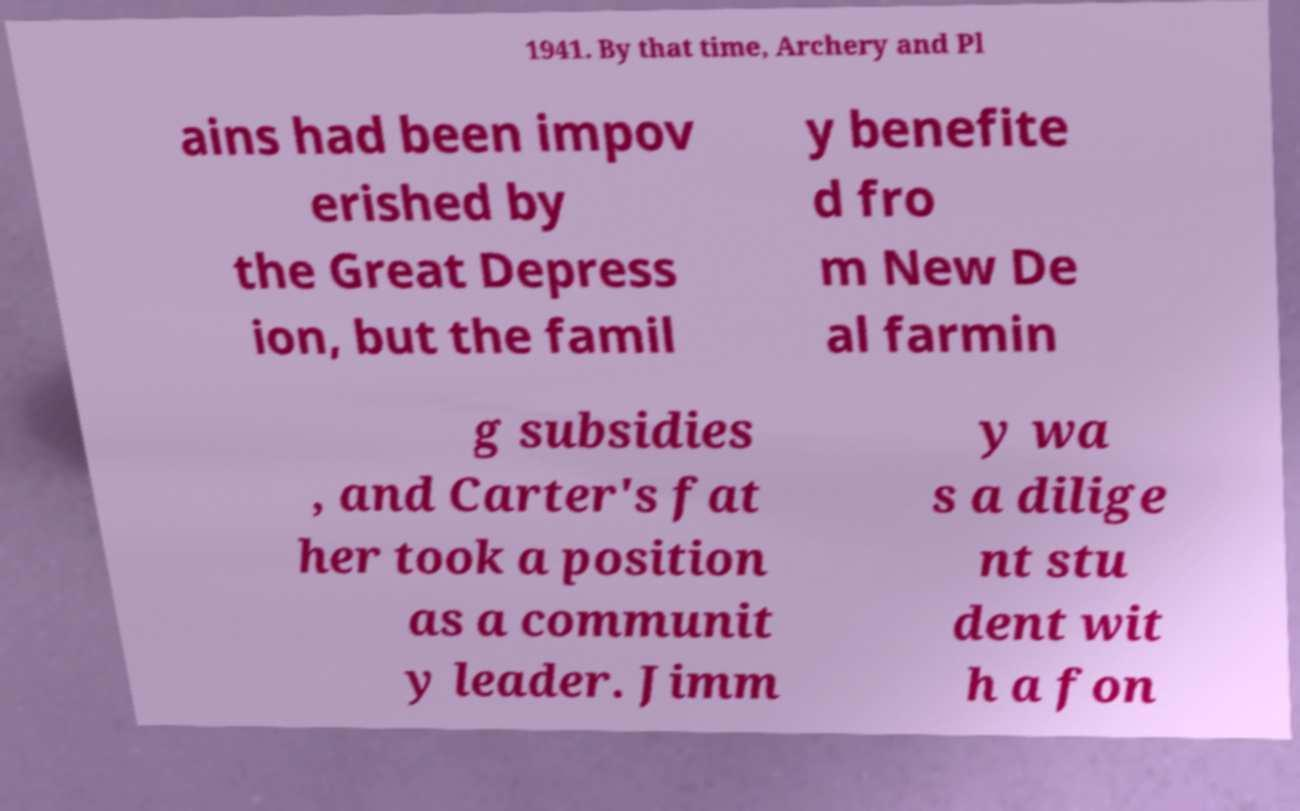Please identify and transcribe the text found in this image. 1941. By that time, Archery and Pl ains had been impov erished by the Great Depress ion, but the famil y benefite d fro m New De al farmin g subsidies , and Carter's fat her took a position as a communit y leader. Jimm y wa s a dilige nt stu dent wit h a fon 